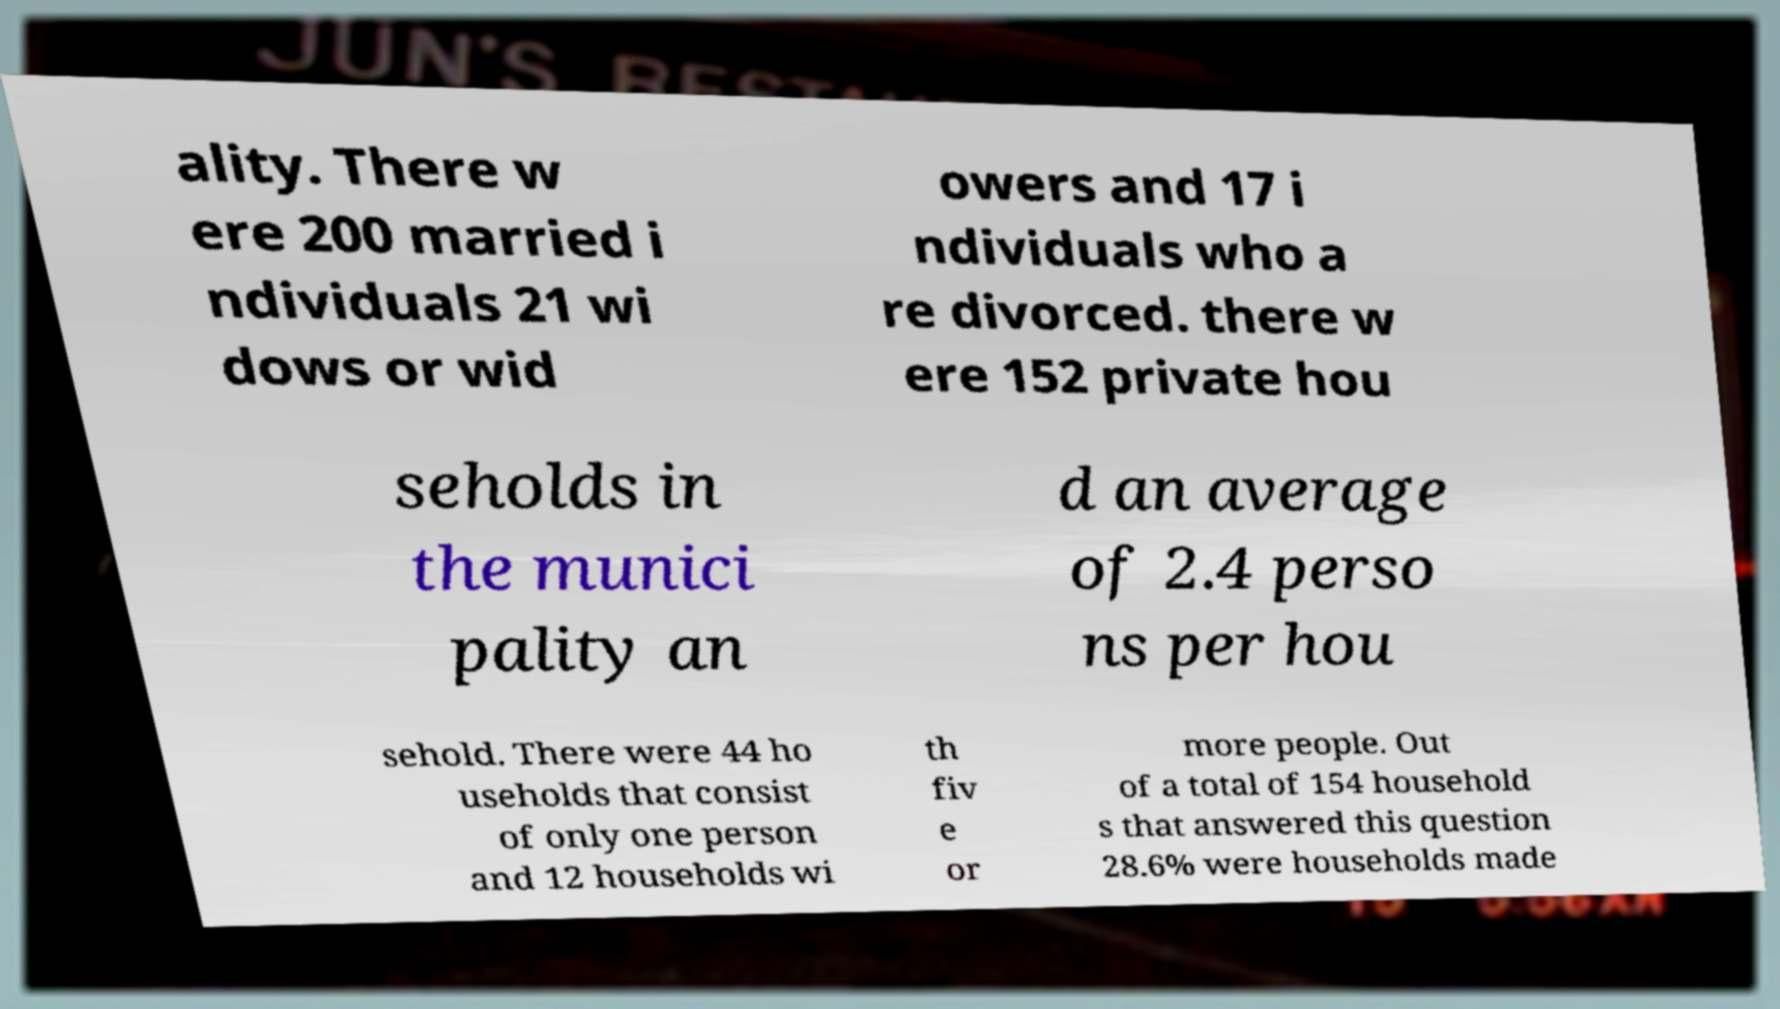Could you assist in decoding the text presented in this image and type it out clearly? ality. There w ere 200 married i ndividuals 21 wi dows or wid owers and 17 i ndividuals who a re divorced. there w ere 152 private hou seholds in the munici pality an d an average of 2.4 perso ns per hou sehold. There were 44 ho useholds that consist of only one person and 12 households wi th fiv e or more people. Out of a total of 154 household s that answered this question 28.6% were households made 